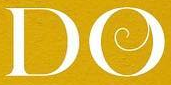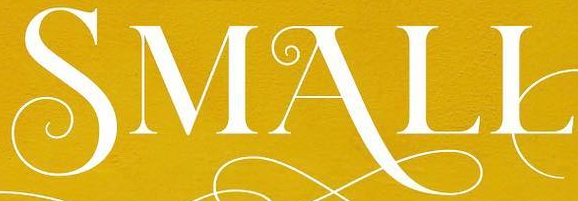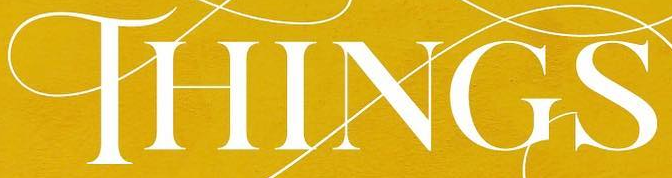What text is displayed in these images sequentially, separated by a semicolon? DO; SMALL; THINGS 